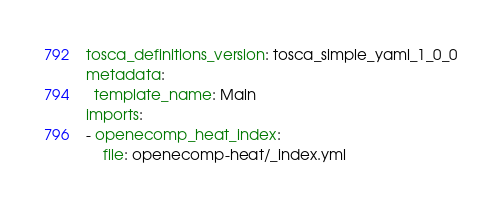<code> <loc_0><loc_0><loc_500><loc_500><_YAML_>tosca_definitions_version: tosca_simple_yaml_1_0_0
metadata:
  template_name: Main
imports:
- openecomp_heat_index:
    file: openecomp-heat/_index.yml</code> 